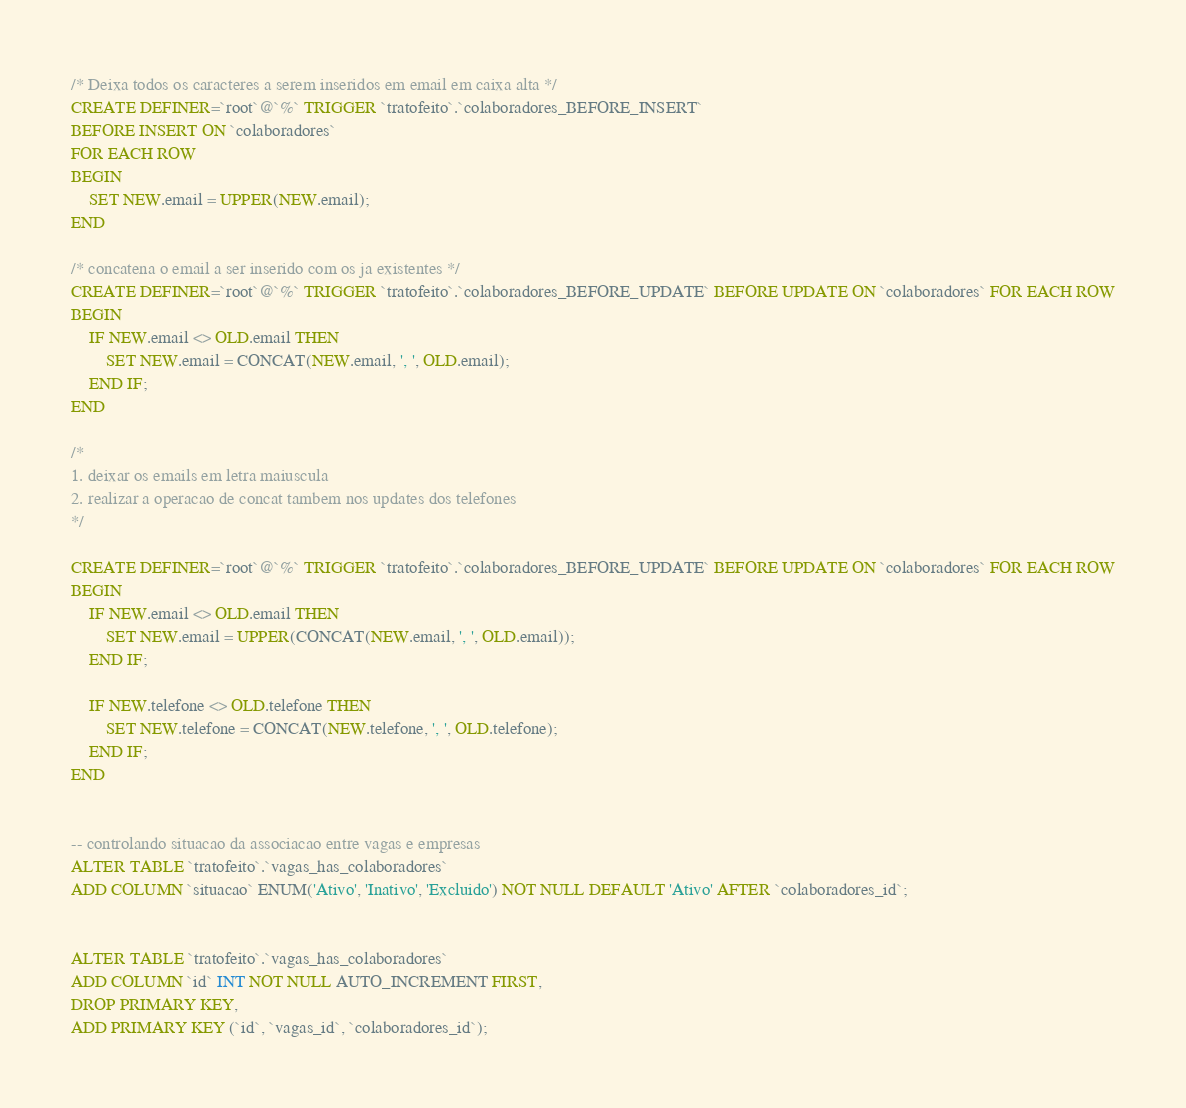Convert code to text. <code><loc_0><loc_0><loc_500><loc_500><_SQL_>/* Deixa todos os caracteres a serem inseridos em email em caixa alta */
CREATE DEFINER=`root`@`%` TRIGGER `tratofeito`.`colaboradores_BEFORE_INSERT` 
BEFORE INSERT ON `colaboradores` 
FOR EACH ROW
BEGIN
	SET NEW.email = UPPER(NEW.email);
END

/* concatena o email a ser inserido com os ja existentes */
CREATE DEFINER=`root`@`%` TRIGGER `tratofeito`.`colaboradores_BEFORE_UPDATE` BEFORE UPDATE ON `colaboradores` FOR EACH ROW
BEGIN
	IF NEW.email <> OLD.email THEN
		SET NEW.email = CONCAT(NEW.email, ', ', OLD.email);
    END IF;
END

/*
1. deixar os emails em letra maiuscula
2. realizar a operacao de concat tambem nos updates dos telefones
*/

CREATE DEFINER=`root`@`%` TRIGGER `tratofeito`.`colaboradores_BEFORE_UPDATE` BEFORE UPDATE ON `colaboradores` FOR EACH ROW
BEGIN
	IF NEW.email <> OLD.email THEN
		SET NEW.email = UPPER(CONCAT(NEW.email, ', ', OLD.email));
    END IF;
    
    IF NEW.telefone <> OLD.telefone THEN
		SET NEW.telefone = CONCAT(NEW.telefone, ', ', OLD.telefone);
    END IF;
END


-- controlando situacao da associacao entre vagas e empresas
ALTER TABLE `tratofeito`.`vagas_has_colaboradores` 
ADD COLUMN `situacao` ENUM('Ativo', 'Inativo', 'Excluido') NOT NULL DEFAULT 'Ativo' AFTER `colaboradores_id`;


ALTER TABLE `tratofeito`.`vagas_has_colaboradores` 
ADD COLUMN `id` INT NOT NULL AUTO_INCREMENT FIRST,
DROP PRIMARY KEY,
ADD PRIMARY KEY (`id`, `vagas_id`, `colaboradores_id`);
</code> 